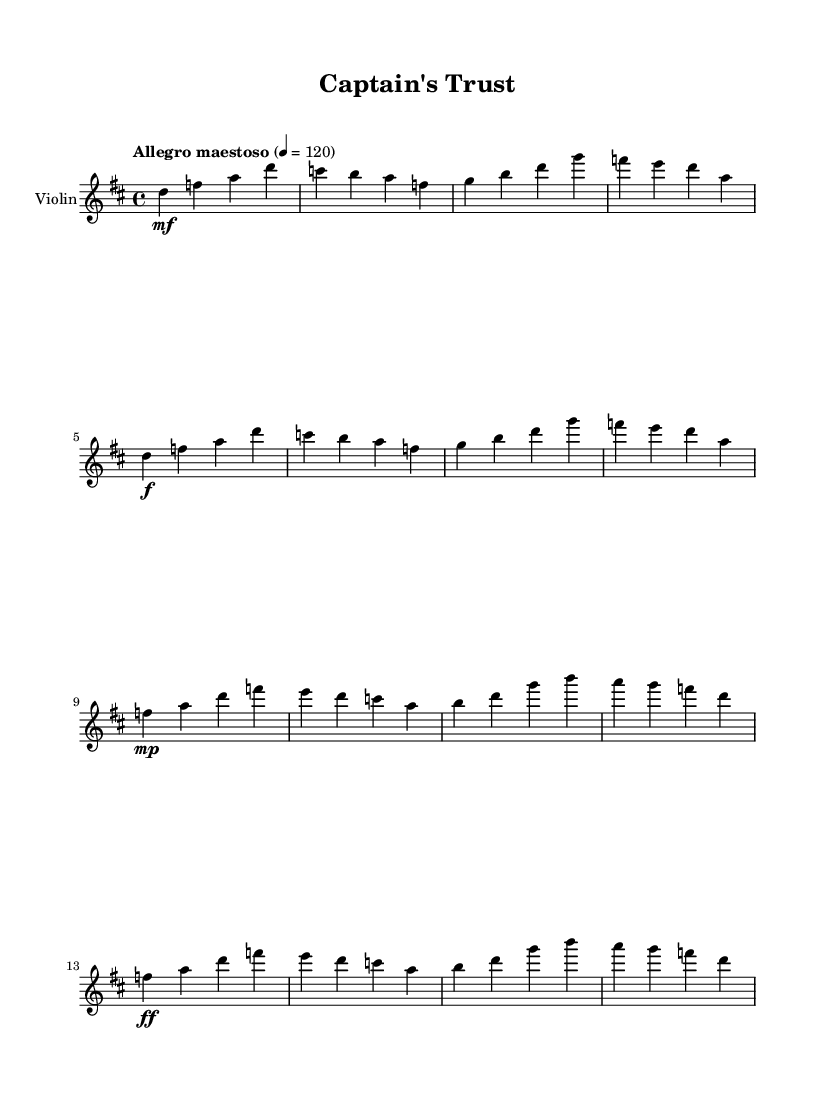What is the key signature of this music? The key signature is indicated at the beginning of the sheet music, and it shows two sharps, which corresponds to D major.
Answer: D major What is the time signature of this music? The time signature is noted at the beginning of the sheet music as 4/4, which indicates there are four beats in each measure.
Answer: 4/4 What is the tempo marking of this score? The tempo marking is "Allegro maestoso," and the metronome marking indicates a speed of 120 beats per minute, suggesting a fast-paced and grand feel.
Answer: Allegro maestoso How many distinct themes are present in this piece? By analyzing the structure of the music, it can be observed that there are two distinct themes labeled as Main Theme A and Main Theme B.
Answer: 2 In which section does the dynamic marking change from mezzo-forte to pianissimo? Looking at the dynamics throughout the piece, the score indicates a change from mezzo-forte in the Main Theme A to pianissimo in the Bridge section.
Answer: Bridge What is the dynamic marking for the first measure? The first measure features a mezzo-forte dynamic marking, indicating a moderately loud volume.
Answer: mezzo-forte What does the title "Captain's Trust" suggest about the piece? The title implies a theme of bravery and reliance, which reflects the essence of epic orchestral scores associated with naval battles and heroic sea voyages.
Answer: Themes of bravery and reliance 